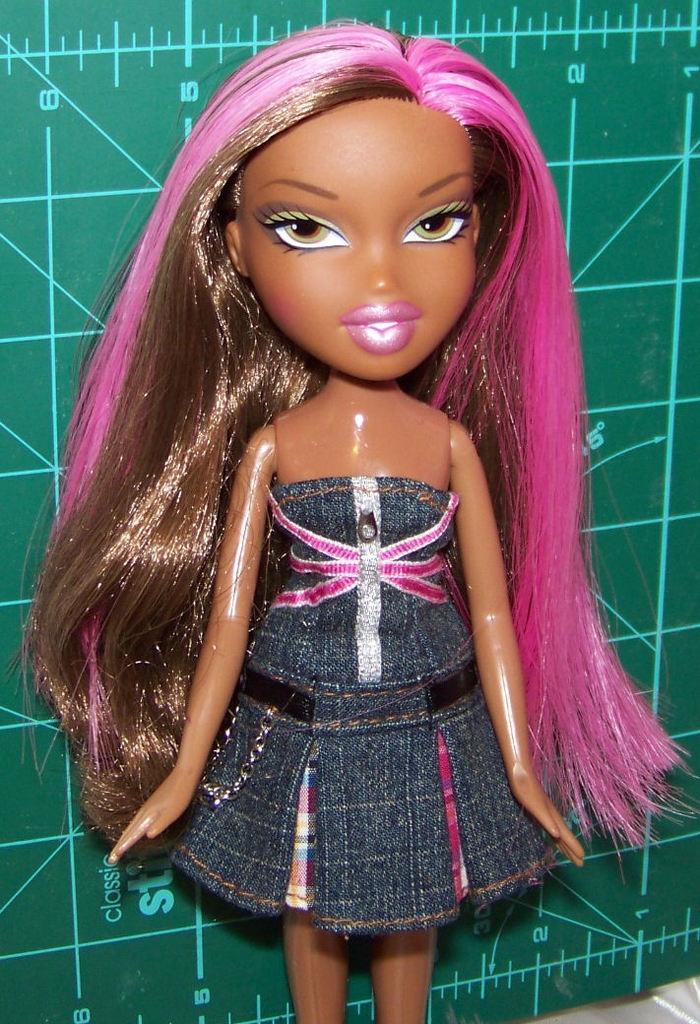Describe this image in one or two sentences. In the middle of this image, there is a doll of a girl. In the background, there is a green color board, on which there are lines. 